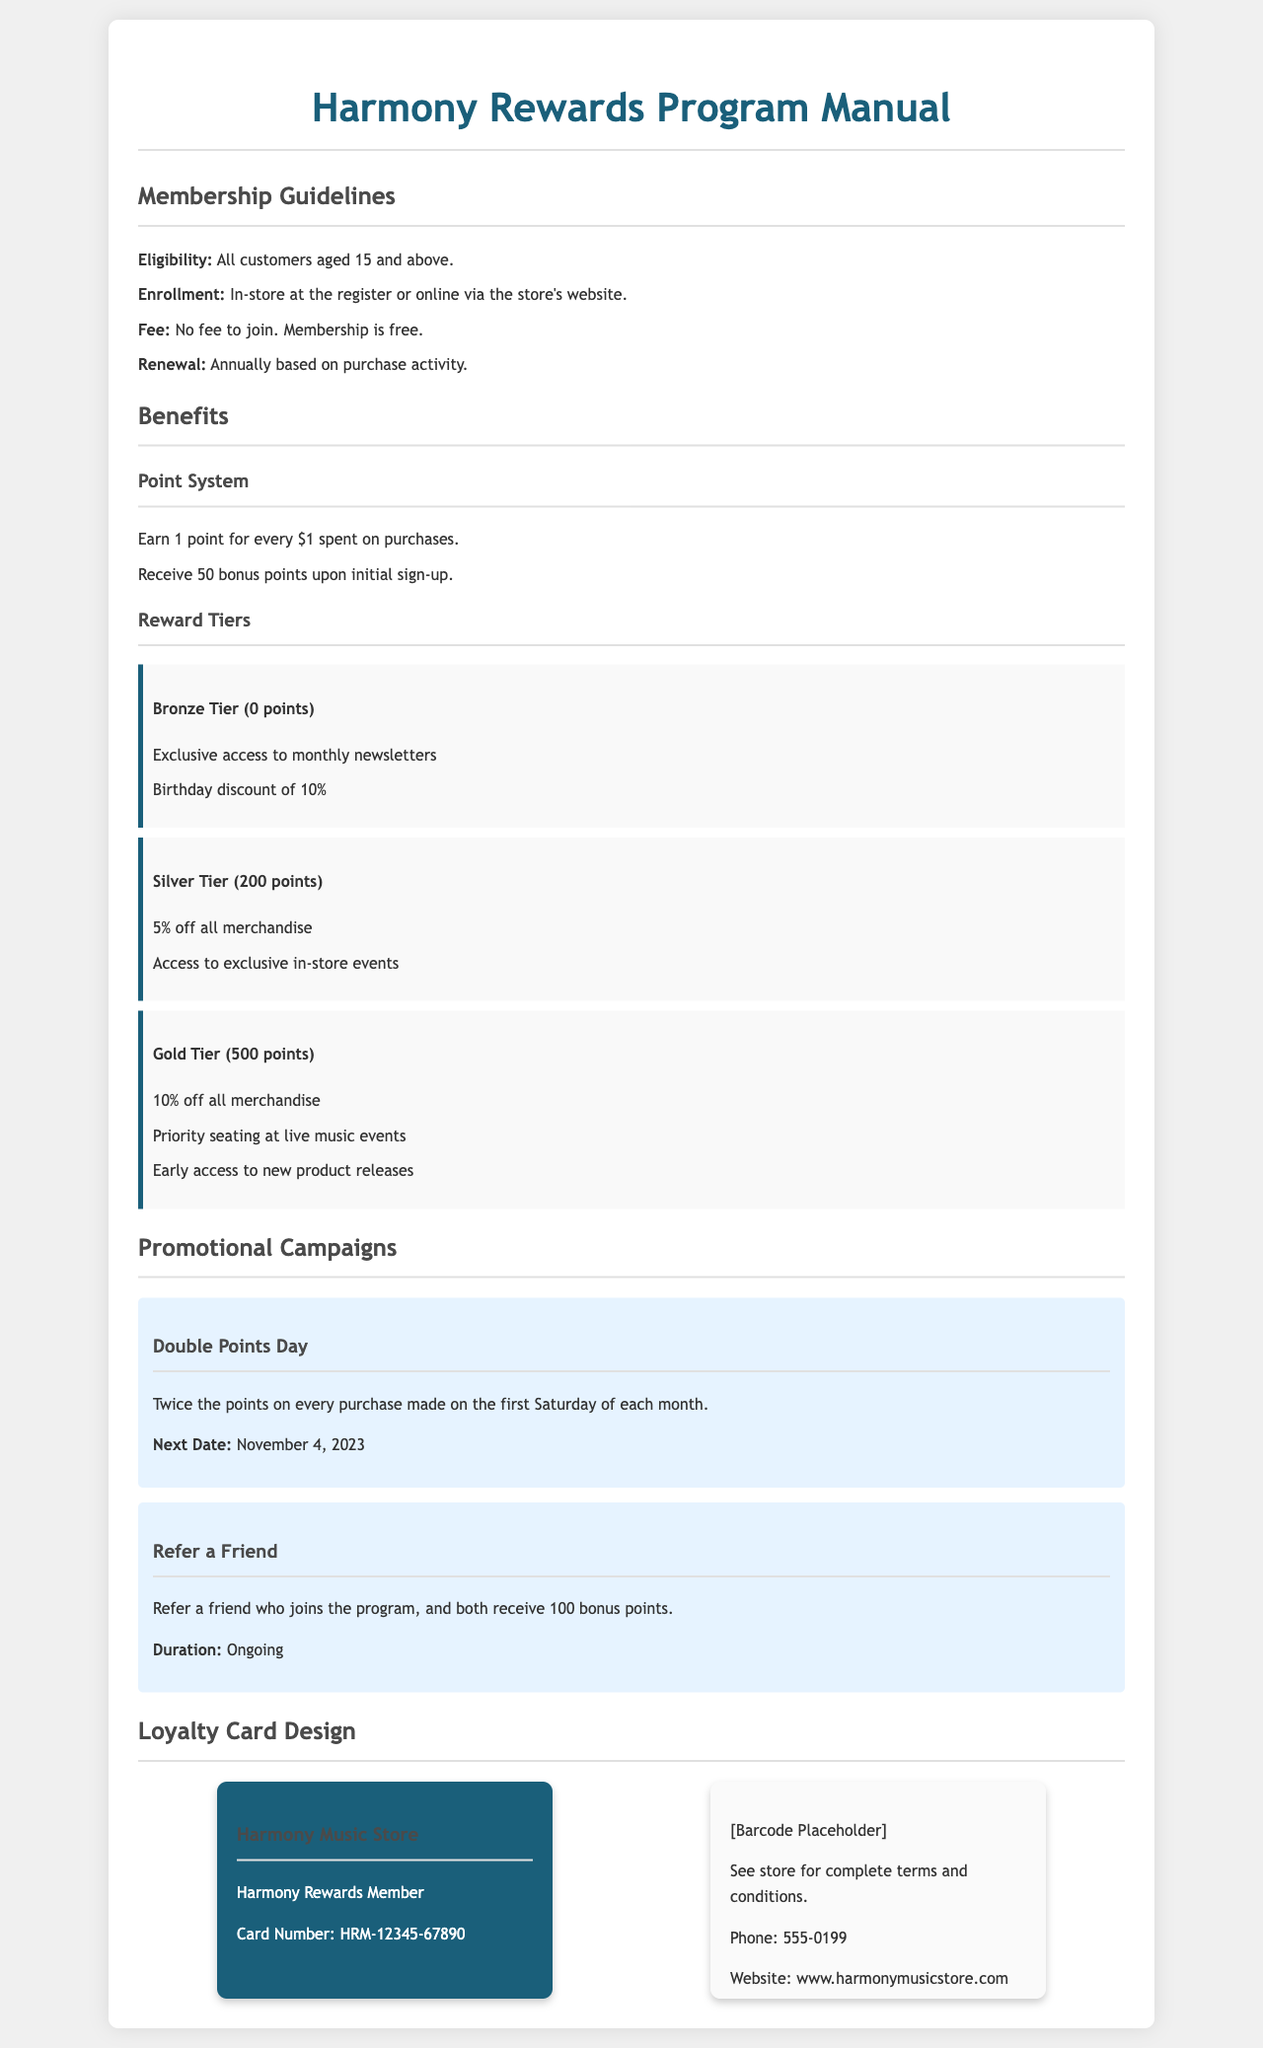What is the minimum age to join the program? The minimum age for eligibility is stated to be 15 years and above.
Answer: 15 What is the enrollment fee for the program? The document specifies that there is no fee to join the program, indicating it's free.
Answer: Free How many points are earned for every dollar spent? According to the point system, members earn 1 point for every dollar spent on purchases.
Answer: 1 point What bonus points do new members receive upon sign-up? The manual mentions that new members receive 50 bonus points upon initial sign-up.
Answer: 50 bonus points What discount do members in the Gold Tier get? The Gold Tier members receive a 10% discount on all merchandise.
Answer: 10% When is the next Double Points Day? The document states that the next Double Points Day is on November 4, 2023.
Answer: November 4, 2023 What is the benefit of the Silver Tier membership? One of the benefits for Silver Tier members is a 5% discount on all merchandise.
Answer: 5% discount How often does the "Refer a Friend" campaign take place? The document describes the "Refer a Friend" campaign as ongoing, indicating it doesn’t have an end date.
Answer: Ongoing What color is the loyalty card designed for members? The loyalty card is designed with a background color of #1a5f7a, which corresponds to a teal shade.
Answer: Teal 